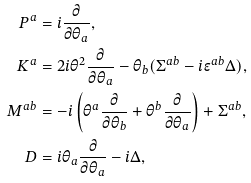<formula> <loc_0><loc_0><loc_500><loc_500>P ^ { a } & = i \frac { \partial } { \partial \theta _ { a } } , \\ K ^ { a } & = 2 i \theta ^ { 2 } \frac { \partial } { \partial \theta _ { a } } - \theta _ { b } ( \Sigma ^ { a b } - i \epsilon ^ { a b } \Delta ) , \\ M ^ { a b } & = - i \left ( \theta ^ { a } \frac { \partial } { \partial \theta _ { b } } + \theta ^ { b } \frac { \partial } { \partial \theta _ { a } } \right ) + \Sigma ^ { a b } , \\ D & = i \theta _ { a } \frac { \partial } { \partial \theta _ { a } } - i \Delta ,</formula> 